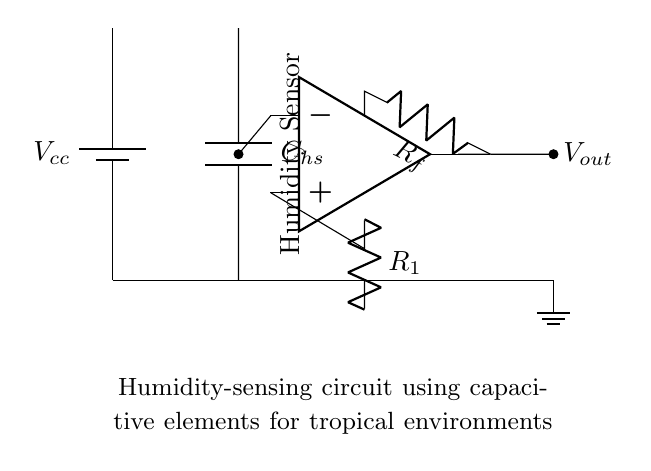What is the type of sensor used in this circuit? The circuit uses a capacitive humidity sensor, indicated by "C_hs" representing the capacitive element that senses humidity changes.
Answer: capacitive humidity sensor What is the output voltage variable in the circuit? The output voltage is labeled as "V_out," which is connected from the output pin of the operational amplifier.
Answer: V_out What component is used for feedback in the operational amplifier? The feedback component is the resistor labeled "R_f," which connects the output of the op-amp back to its inverting input, indicating a feedback loop for gain control.
Answer: R_f What is the purpose of the operational amplifier in this circuit? The operational amplifier amplifies the voltage signal generated by the humidity sensor, facilitating better measurement of humidity levels in the tropical environment.
Answer: amplifying signal What happens to the capacitive humidity sensor when humidity increases? When humidity increases, the capacitance "C_hs" also increases, which results in a change in voltage at the output of the operational amplifier due to the sensor's behavior and its effect on the input to the op-amp.
Answer: increases capacitance What is the function of the resistor labeled R_1? R_1 is used to form a voltage divider with the sensor and allows for scaling of the output voltage according to the sensor's response in this analog measurement circuit.
Answer: scaling output voltage What is the role of the ground symbol in the circuit? The ground symbol provides a reference point for the circuit's voltage levels, ensuring that all measurements and outputs are taken with respect to a common ground potential, which is crucial for circuit stability.
Answer: reference voltage 